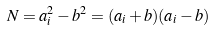Convert formula to latex. <formula><loc_0><loc_0><loc_500><loc_500>N = a _ { i } ^ { 2 } - b ^ { 2 } = ( a _ { i } + b ) ( a _ { i } - b )</formula> 